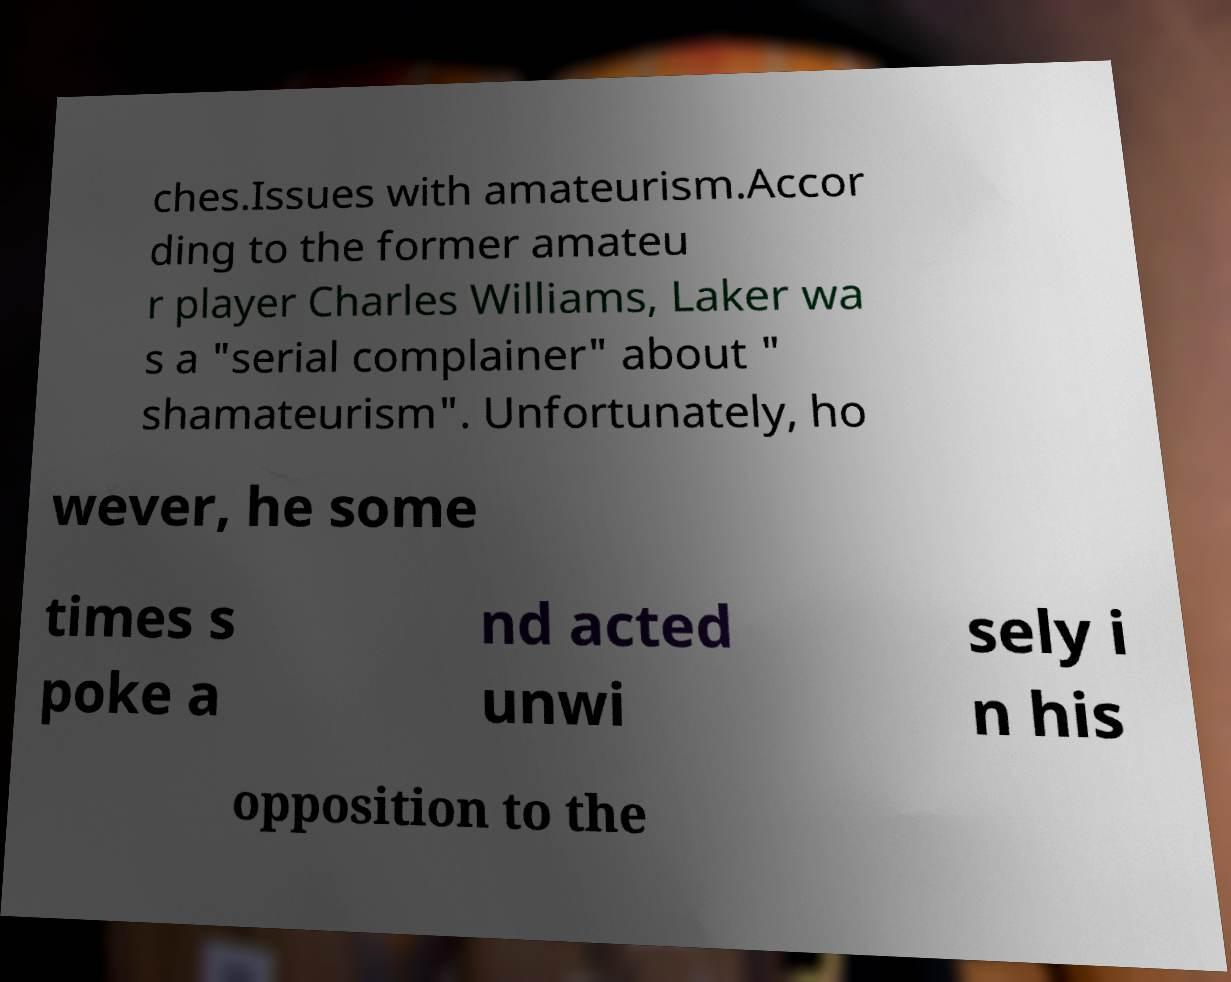I need the written content from this picture converted into text. Can you do that? ches.Issues with amateurism.Accor ding to the former amateu r player Charles Williams, Laker wa s a "serial complainer" about " shamateurism". Unfortunately, ho wever, he some times s poke a nd acted unwi sely i n his opposition to the 